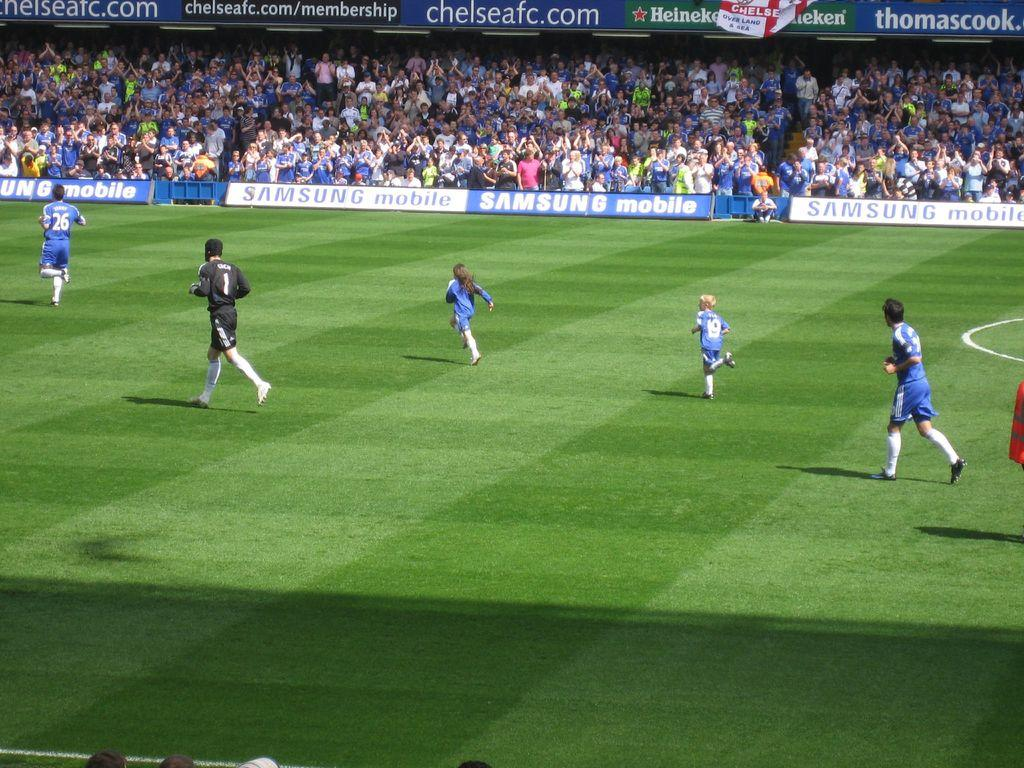<image>
Present a compact description of the photo's key features. a soccer game with sideline signs that read : SAMSUNG Mobile 